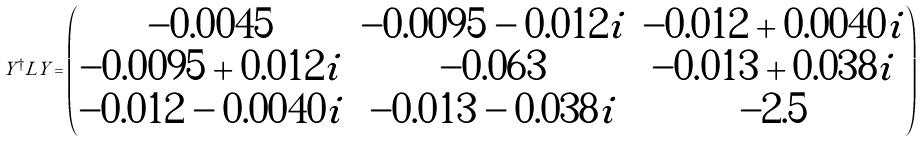<formula> <loc_0><loc_0><loc_500><loc_500>Y ^ { \dagger } L Y = \begin{pmatrix} - 0 . 0 0 4 5 & - 0 . 0 0 9 5 - 0 . 0 1 2 i & - 0 . 0 1 2 + 0 . 0 0 4 0 i \\ - 0 . 0 0 9 5 + 0 . 0 1 2 i & - 0 . 0 6 3 & - 0 . 0 1 3 + 0 . 0 3 8 i \\ - 0 . 0 1 2 - 0 . 0 0 4 0 i & - 0 . 0 1 3 - 0 . 0 3 8 i & - 2 . 5 \end{pmatrix}</formula> 